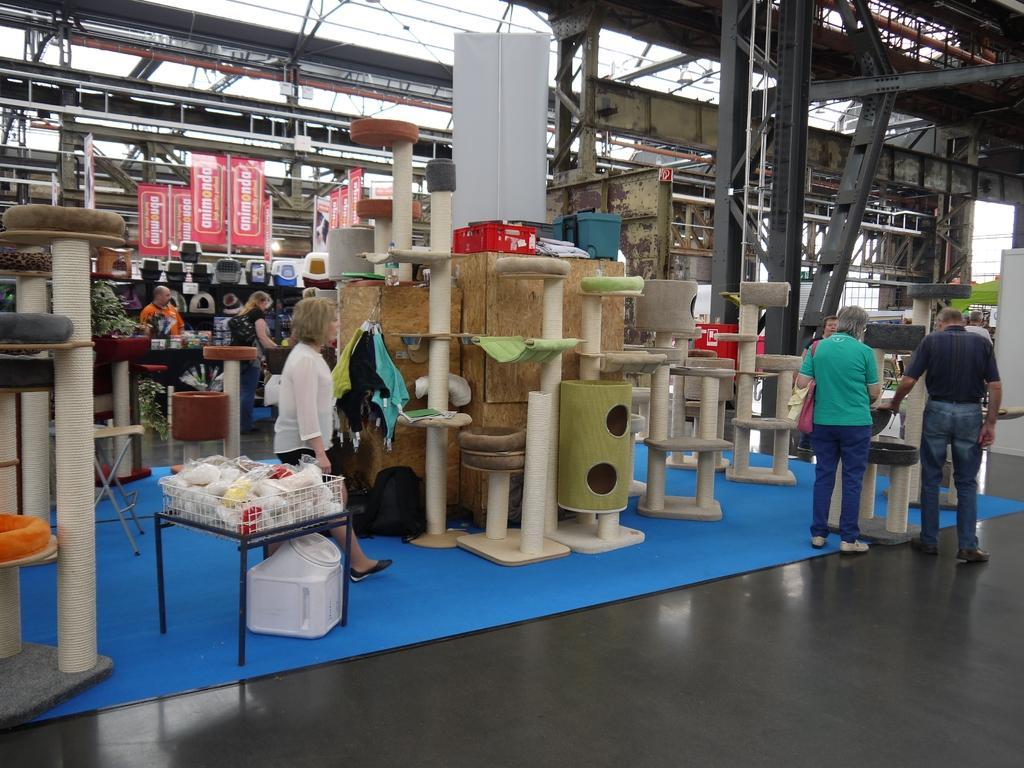Can you describe this image briefly? There are few people standing. This looks like a shop. These are the objects, which are placed on the floor. I can see the banners hanging to the roof. These are the iron pillars. 